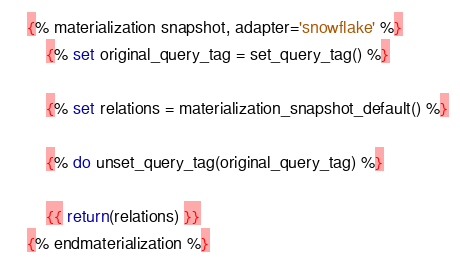<code> <loc_0><loc_0><loc_500><loc_500><_SQL_>{% materialization snapshot, adapter='snowflake' %}
    {% set original_query_tag = set_query_tag() %}

    {% set relations = materialization_snapshot_default() %}

    {% do unset_query_tag(original_query_tag) %}

    {{ return(relations) }}
{% endmaterialization %}
</code> 